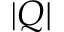<formula> <loc_0><loc_0><loc_500><loc_500>| Q |</formula> 